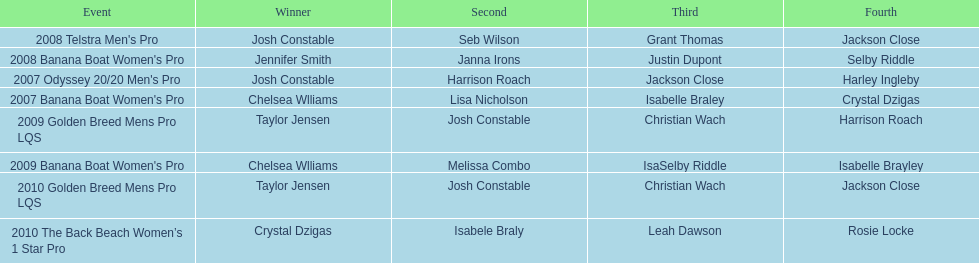In which two competitions did chelsea williams achieve identical rankings? 2007 Banana Boat Women's Pro, 2009 Banana Boat Women's Pro. 